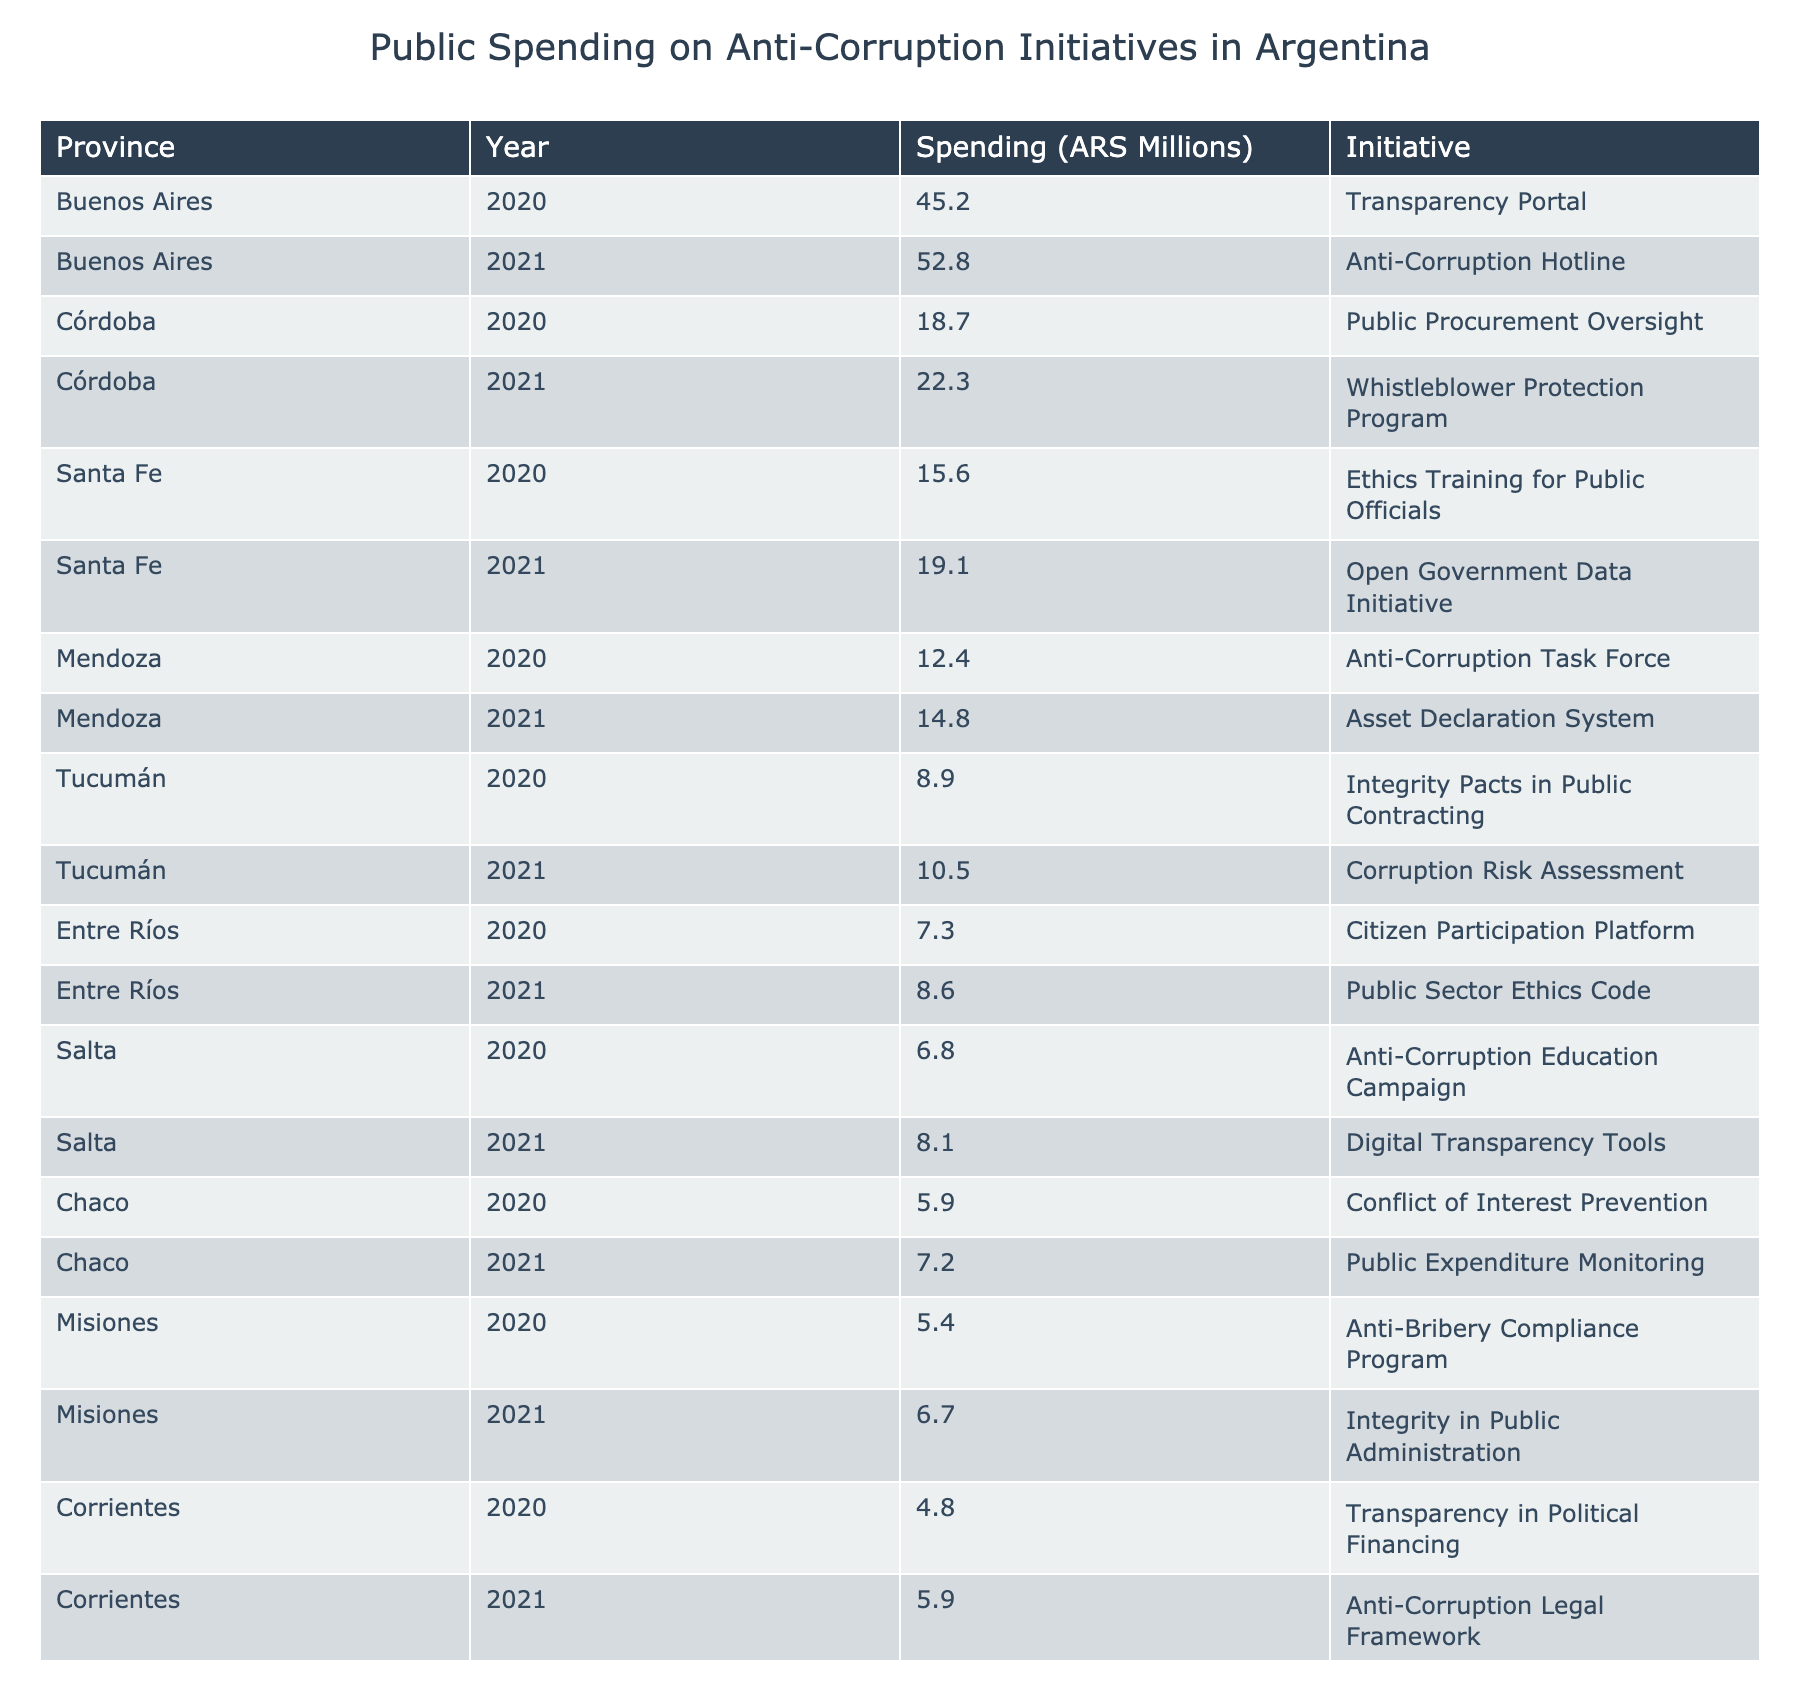What is the total spending on anti-corruption initiatives in Buenos Aires in 2021? From the table, the spending for Buenos Aires in 2021 is listed as 52.8 million ARS.
Answer: 52.8 million ARS Which province had the highest spending on anti-corruption initiatives in 2021? Looking at the 2021 spending data, Buenos Aires has the highest value at 52.8 million ARS compared to other provinces.
Answer: Buenos Aires What is the average spending on anti-corruption initiatives across all provinces in 2020? First, add up the spending for each province in 2020: 45.2 + 18.7 + 15.6 + 12.4 + 8.9 + 7.3 + 6.8 + 5.9 + 5.4 + 4.8 = 125.0 million ARS. Then, divide by the number of provinces (10): 125.0 / 10 = 12.5 million ARS.
Answer: 12.5 million ARS Did Chaco spend more on anti-corruption initiatives in 2021 than in 2020? In 2020, Chaco spent 5.9 million ARS, and in 2021, it spent 7.2 million ARS. Since 7.2 million ARS is greater than 5.9 million ARS, the answer is yes.
Answer: Yes What is the total spending on anti-corruption initiatives in Salta from 2020 to 2021? The spending for Salta in 2020 is 6.8 million ARS and in 2021 is 8.1 million ARS. Adding these together: 6.8 + 8.1 = 14.9 million ARS.
Answer: 14.9 million ARS Which initiative had the lowest funding in 2020? The lowest amount spent in 2020 is in Corrientes, with 4.8 million ARS allocated to the "Transparency in Political Financing" initiative.
Answer: Transparency in Political Financing What is the difference in spending on anti-corruption initiatives between Santa Fe in 2020 and Mendoza in 2021? Santa Fe spent 15.6 million ARS in 2020 and Mendoza spent 14.8 million ARS in 2021. The difference is 15.6 - 14.8 = 0.8 million ARS.
Answer: 0.8 million ARS How much did Entre Ríos increase its spending from 2020 to 2021? In 2020, Entre Ríos's spending was 7.3 million ARS, and in 2021 it was 8.6 million ARS. The increase is 8.6 - 7.3 = 1.3 million ARS.
Answer: 1.3 million ARS Is the total spending on anti-corruption initiatives in Córdoba greater than that in Santa Fe over both years? Córdoba spent 18.7 million ARS in 2020 and 22.3 million ARS in 2021 (total: 41 million ARS), whereas Santa Fe spent 15.6 million ARS in 2020 and 19.1 million ARS in 2021 (total: 34.7 million ARS). Since 41 million ARS > 34.7 million ARS, the answer is yes.
Answer: Yes What was the spending trend in Tucumán from 2020 to 2021? Tucumán's spending was 8.9 million ARS in 2020 and increased to 10.5 million ARS in 2021, indicating a positive trend.
Answer: Positive trend 